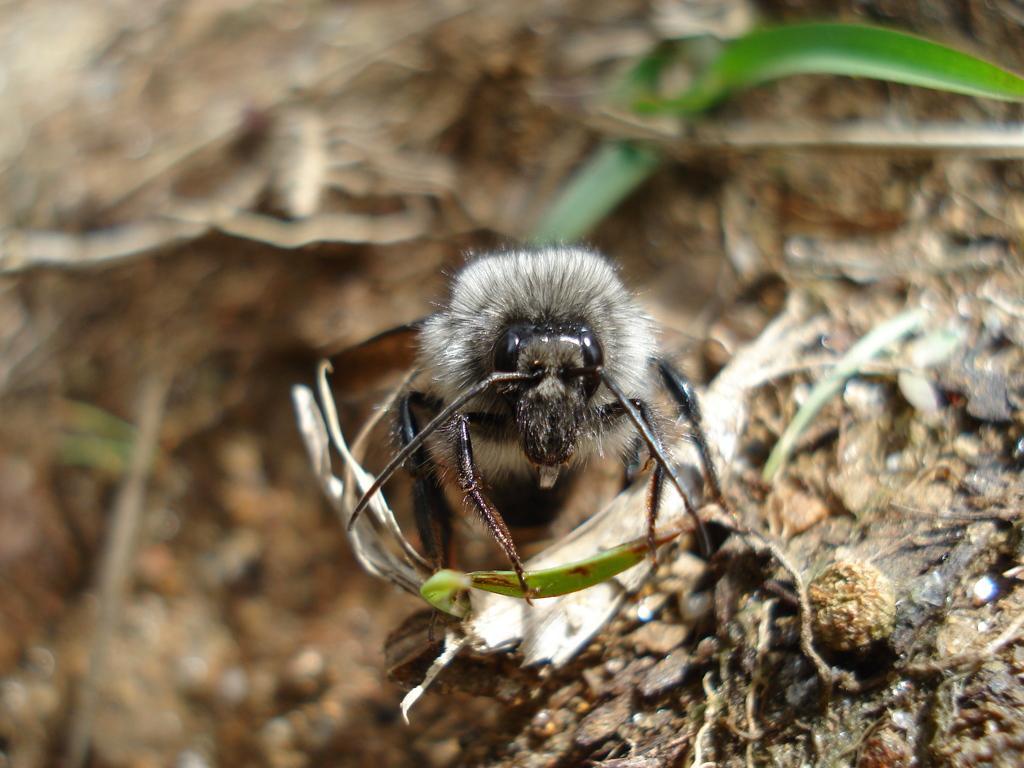How would you summarize this image in a sentence or two? This image consists of an insect. At the bottom, there are dried leaves on the ground. 